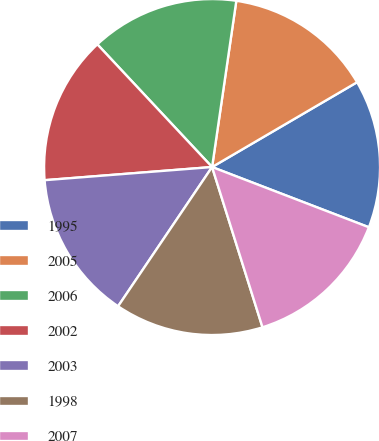Convert chart to OTSL. <chart><loc_0><loc_0><loc_500><loc_500><pie_chart><fcel>1995<fcel>2005<fcel>2006<fcel>2002<fcel>2003<fcel>1998<fcel>2007<nl><fcel>14.26%<fcel>14.27%<fcel>14.27%<fcel>14.28%<fcel>14.3%<fcel>14.3%<fcel>14.31%<nl></chart> 